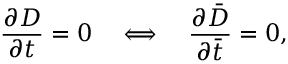<formula> <loc_0><loc_0><loc_500><loc_500>\frac { \partial D } { \partial t } = 0 \quad \Longleftrightarrow \quad \frac { \partial \bar { D } } { \partial \bar { t } } = 0 ,</formula> 